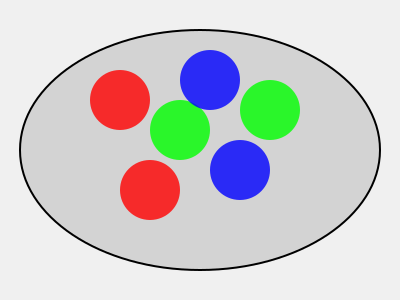Yo, check out this epic laundry disaster! How many pairs of mismatched socks can you make from this chaotic pile? It's like a wild sock party in there! Alright, let's break this down, homie:

1. First, we gotta count the socks. There are 6 socks in total.

2. Now, let's look at the colors:
   - 2 red socks
   - 2 green socks
   - 2 blue socks

3. To make mismatched pairs, we need to pair socks of different colors.

4. We can do this in a few ways:
   - Red + Green
   - Red + Blue
   - Green + Blue

5. Now, here's the cool part: for each of these color combos, we have 2 choices for each color.

6. So, for each color combo, we can make 2 different mismatched pairs.

7. With 3 color combos, and 2 pairs per combo, we get:
   $3 \times 2 = 6$ total mismatched pairs

8. But wait! We're not done yet! Remember, switching the order (like left foot red, right foot blue vs. left foot blue, right foot red) doesn't count as a new pair. We've double-counted!

9. So, we need to divide our total by 2:
   $\frac{6}{2} = 3$

And there you have it! We can make 3 unique mismatched pairs from this crazy sock party!
Answer: 3 pairs 